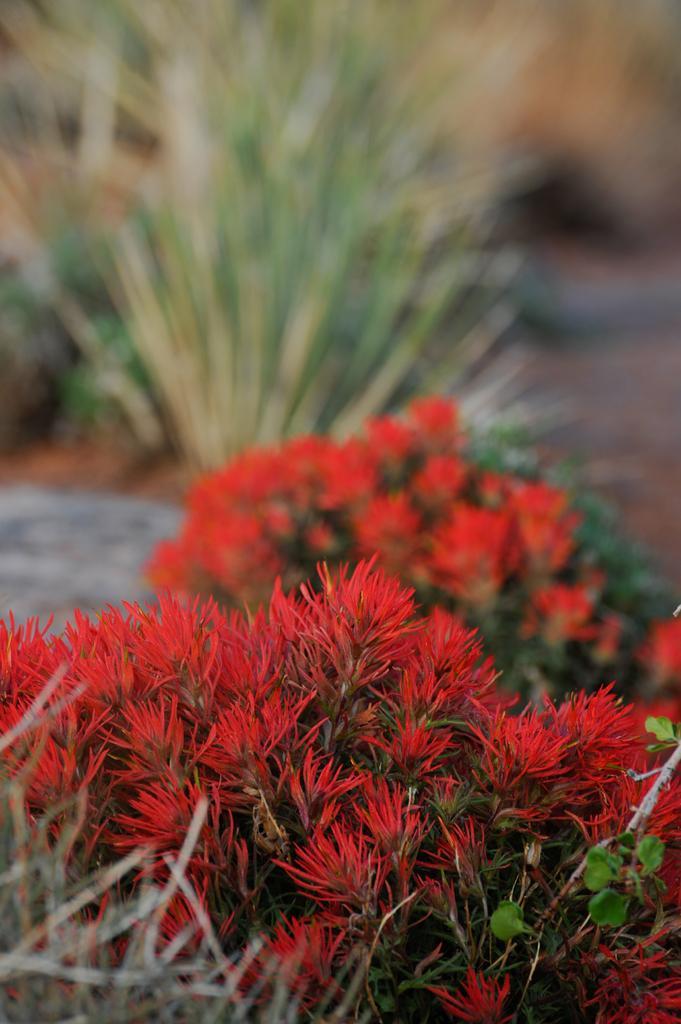Can you describe this image briefly? In this image at the bottom, there are plants and flowers. In the background there are plants and land. 